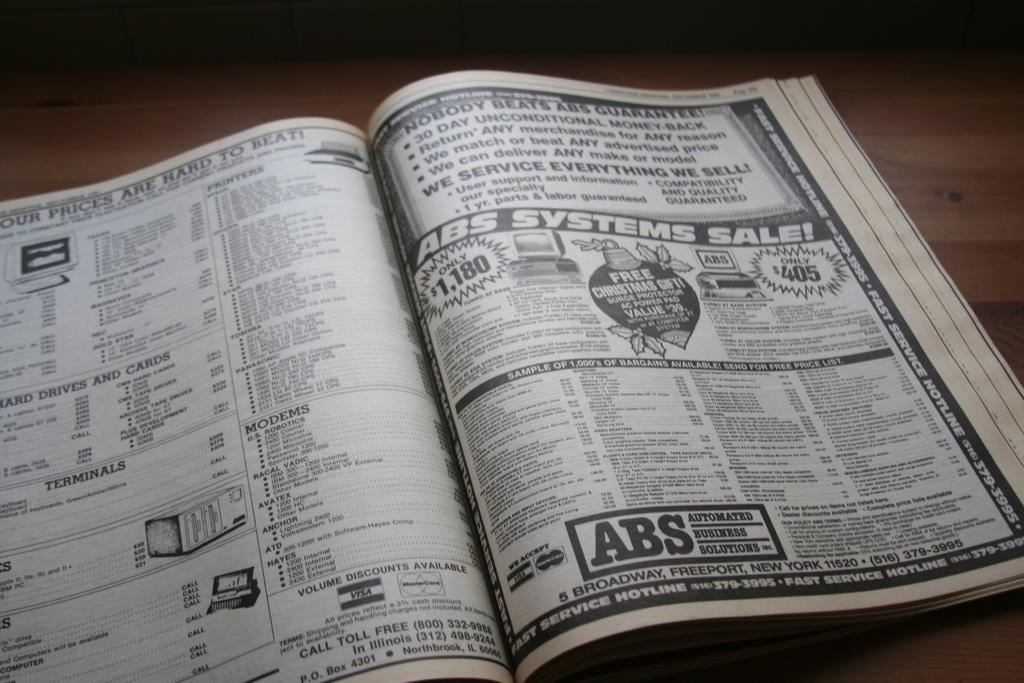Provide a one-sentence caption for the provided image. A telephone book is open on a table showing ABS Systems. 